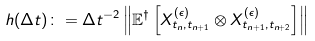<formula> <loc_0><loc_0><loc_500><loc_500>h ( \Delta t ) \colon = \Delta t ^ { - 2 } \left \| \mathbb { E } ^ { \dagger } \left [ X ^ { ( \epsilon ) } _ { t _ { n } , t _ { n + 1 } } \otimes X ^ { ( \epsilon ) } _ { t _ { n + 1 } , t _ { n + 2 } } \right ] \right \|</formula> 